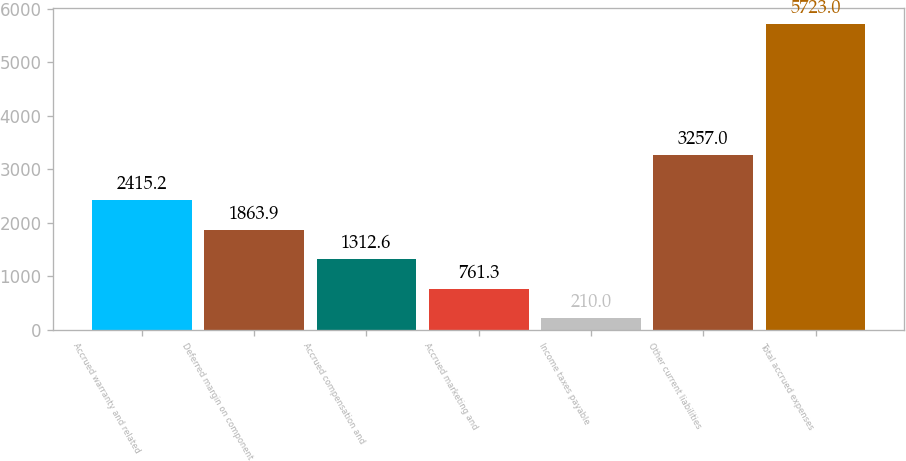Convert chart. <chart><loc_0><loc_0><loc_500><loc_500><bar_chart><fcel>Accrued warranty and related<fcel>Deferred margin on component<fcel>Accrued compensation and<fcel>Accrued marketing and<fcel>Income taxes payable<fcel>Other current liabilities<fcel>Total accrued expenses<nl><fcel>2415.2<fcel>1863.9<fcel>1312.6<fcel>761.3<fcel>210<fcel>3257<fcel>5723<nl></chart> 